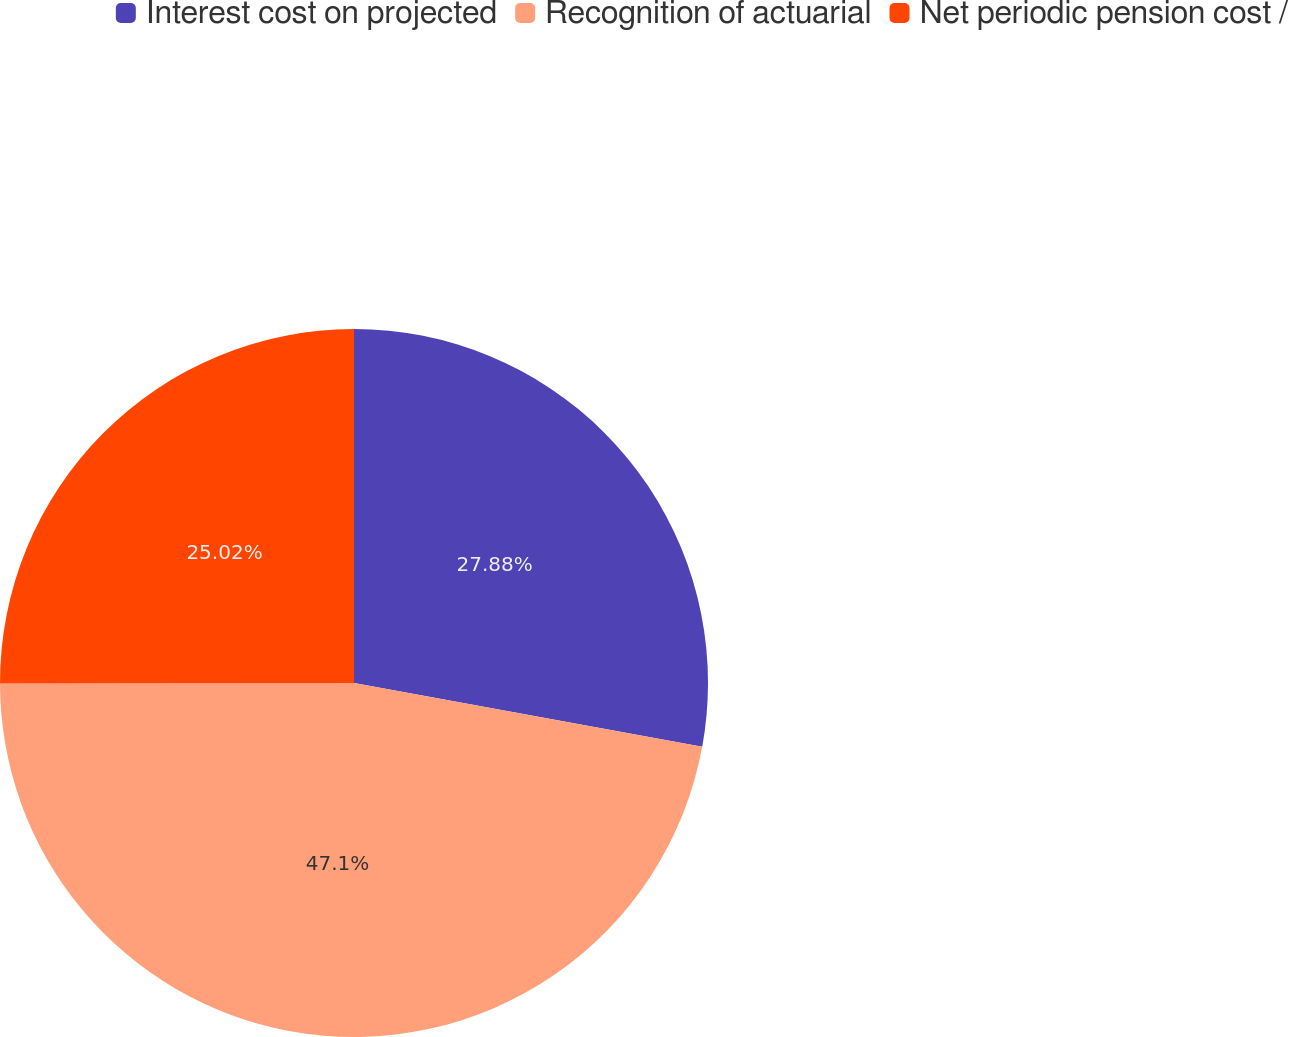Convert chart. <chart><loc_0><loc_0><loc_500><loc_500><pie_chart><fcel>Interest cost on projected<fcel>Recognition of actuarial<fcel>Net periodic pension cost /<nl><fcel>27.88%<fcel>47.09%<fcel>25.02%<nl></chart> 